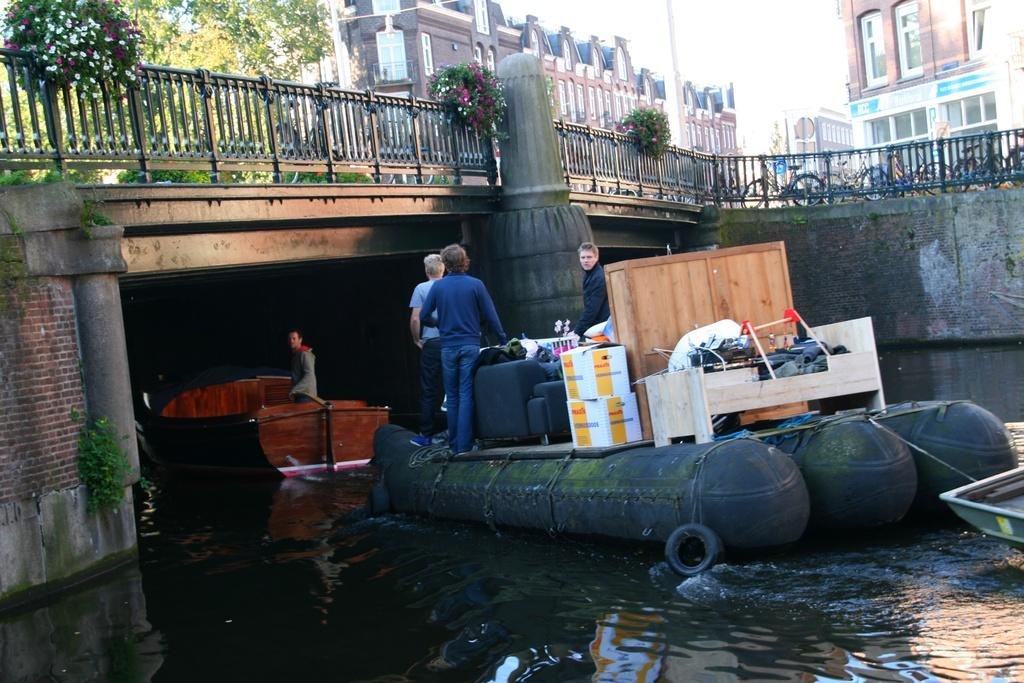What is the main subject of the image? The main subject of the image is a boat. What can be seen on the boat? There are many things kept on the boat. What is visible at the bottom of the image? There is water visible at the bottom of the image. What is located to the left of the image? There is a bridge to the left of the image. What can be seen in the background of the image? There are buildings and trees in the background of the image. How many hens are sitting on the boat in the image? There are no hens present in the image; it features a boat with many things on it. What type of air is visible in the image? The image does not depict a specific type of air; it simply shows a boat on water with a bridge and buildings in the background. 